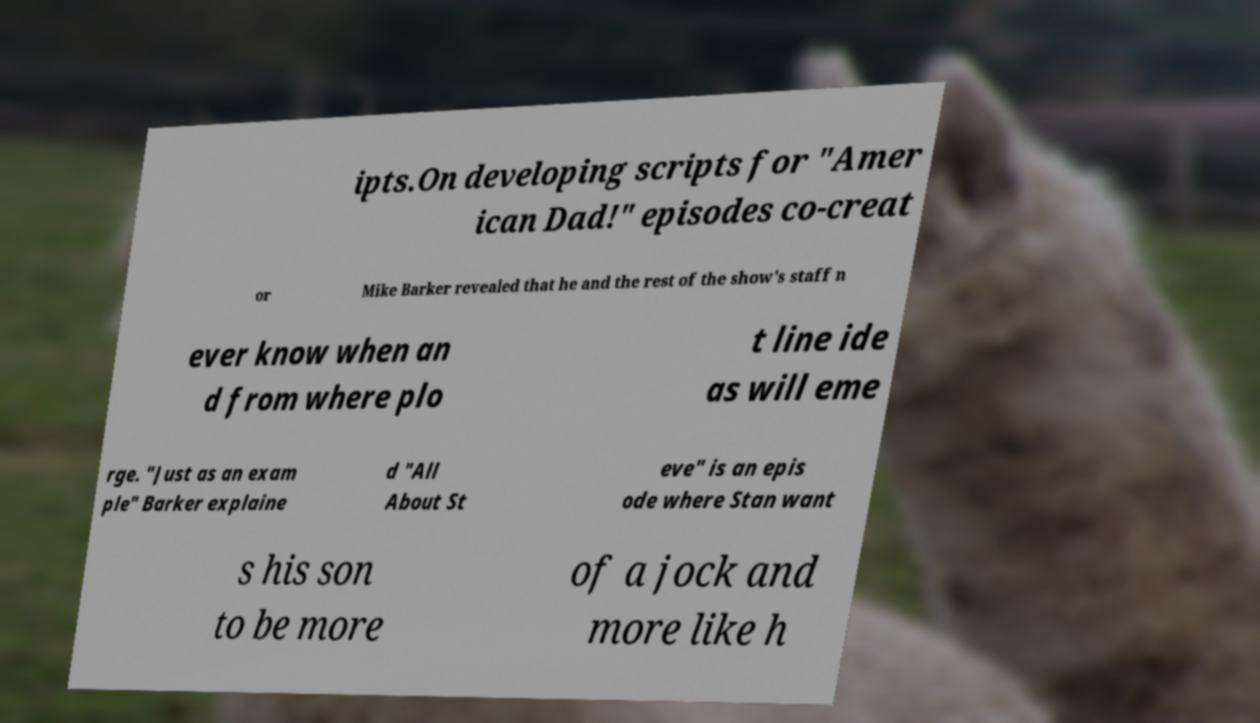What messages or text are displayed in this image? I need them in a readable, typed format. ipts.On developing scripts for "Amer ican Dad!" episodes co-creat or Mike Barker revealed that he and the rest of the show's staff n ever know when an d from where plo t line ide as will eme rge. "Just as an exam ple" Barker explaine d "All About St eve" is an epis ode where Stan want s his son to be more of a jock and more like h 